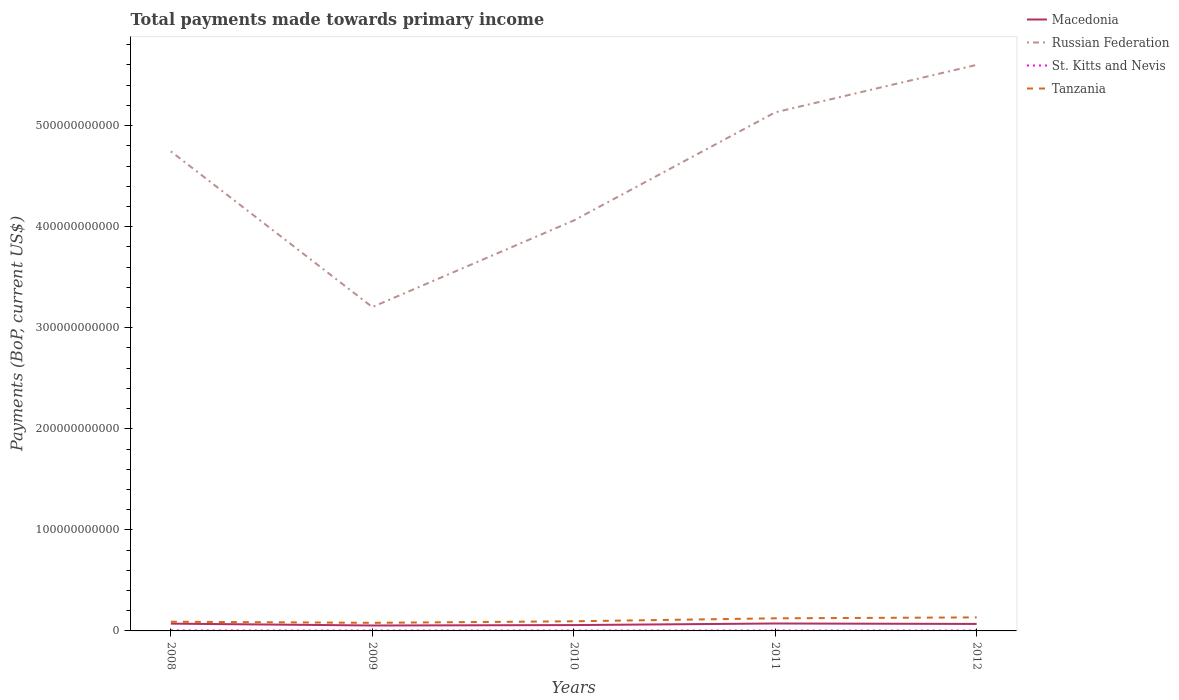How many different coloured lines are there?
Offer a very short reply. 4. Does the line corresponding to Macedonia intersect with the line corresponding to Tanzania?
Your answer should be very brief. No. Across all years, what is the maximum total payments made towards primary income in Macedonia?
Provide a succinct answer. 5.38e+09. In which year was the total payments made towards primary income in Tanzania maximum?
Give a very brief answer. 2009. What is the total total payments made towards primary income in Macedonia in the graph?
Ensure brevity in your answer.  -1.54e+09. What is the difference between the highest and the second highest total payments made towards primary income in Russian Federation?
Provide a short and direct response. 2.40e+11. What is the difference between the highest and the lowest total payments made towards primary income in Russian Federation?
Your response must be concise. 3. How many years are there in the graph?
Ensure brevity in your answer.  5. What is the difference between two consecutive major ticks on the Y-axis?
Offer a very short reply. 1.00e+11. Are the values on the major ticks of Y-axis written in scientific E-notation?
Ensure brevity in your answer.  No. Does the graph contain grids?
Ensure brevity in your answer.  No. Where does the legend appear in the graph?
Keep it short and to the point. Top right. How many legend labels are there?
Provide a succinct answer. 4. What is the title of the graph?
Your response must be concise. Total payments made towards primary income. What is the label or title of the X-axis?
Give a very brief answer. Years. What is the label or title of the Y-axis?
Provide a short and direct response. Payments (BoP, current US$). What is the Payments (BoP, current US$) of Macedonia in 2008?
Your answer should be compact. 7.21e+09. What is the Payments (BoP, current US$) in Russian Federation in 2008?
Offer a terse response. 4.75e+11. What is the Payments (BoP, current US$) of St. Kitts and Nevis in 2008?
Your answer should be compact. 4.81e+08. What is the Payments (BoP, current US$) in Tanzania in 2008?
Make the answer very short. 9.11e+09. What is the Payments (BoP, current US$) in Macedonia in 2009?
Make the answer very short. 5.38e+09. What is the Payments (BoP, current US$) of Russian Federation in 2009?
Ensure brevity in your answer.  3.20e+11. What is the Payments (BoP, current US$) in St. Kitts and Nevis in 2009?
Offer a very short reply. 4.11e+08. What is the Payments (BoP, current US$) in Tanzania in 2009?
Ensure brevity in your answer.  8.02e+09. What is the Payments (BoP, current US$) in Macedonia in 2010?
Offer a terse response. 5.79e+09. What is the Payments (BoP, current US$) in Russian Federation in 2010?
Keep it short and to the point. 4.06e+11. What is the Payments (BoP, current US$) of St. Kitts and Nevis in 2010?
Ensure brevity in your answer.  4.01e+08. What is the Payments (BoP, current US$) in Tanzania in 2010?
Give a very brief answer. 9.54e+09. What is the Payments (BoP, current US$) in Macedonia in 2011?
Provide a short and direct response. 7.35e+09. What is the Payments (BoP, current US$) in Russian Federation in 2011?
Provide a succinct answer. 5.13e+11. What is the Payments (BoP, current US$) in St. Kitts and Nevis in 2011?
Your answer should be very brief. 3.98e+08. What is the Payments (BoP, current US$) in Tanzania in 2011?
Your response must be concise. 1.25e+1. What is the Payments (BoP, current US$) of Macedonia in 2012?
Your answer should be compact. 6.92e+09. What is the Payments (BoP, current US$) of Russian Federation in 2012?
Provide a short and direct response. 5.60e+11. What is the Payments (BoP, current US$) of St. Kitts and Nevis in 2012?
Your answer should be compact. 3.76e+08. What is the Payments (BoP, current US$) in Tanzania in 2012?
Give a very brief answer. 1.34e+1. Across all years, what is the maximum Payments (BoP, current US$) of Macedonia?
Your answer should be very brief. 7.35e+09. Across all years, what is the maximum Payments (BoP, current US$) in Russian Federation?
Your answer should be very brief. 5.60e+11. Across all years, what is the maximum Payments (BoP, current US$) in St. Kitts and Nevis?
Give a very brief answer. 4.81e+08. Across all years, what is the maximum Payments (BoP, current US$) in Tanzania?
Provide a succinct answer. 1.34e+1. Across all years, what is the minimum Payments (BoP, current US$) in Macedonia?
Keep it short and to the point. 5.38e+09. Across all years, what is the minimum Payments (BoP, current US$) in Russian Federation?
Provide a short and direct response. 3.20e+11. Across all years, what is the minimum Payments (BoP, current US$) of St. Kitts and Nevis?
Keep it short and to the point. 3.76e+08. Across all years, what is the minimum Payments (BoP, current US$) of Tanzania?
Ensure brevity in your answer.  8.02e+09. What is the total Payments (BoP, current US$) in Macedonia in the graph?
Your answer should be very brief. 3.26e+1. What is the total Payments (BoP, current US$) in Russian Federation in the graph?
Your response must be concise. 2.27e+12. What is the total Payments (BoP, current US$) in St. Kitts and Nevis in the graph?
Make the answer very short. 2.07e+09. What is the total Payments (BoP, current US$) of Tanzania in the graph?
Give a very brief answer. 5.25e+1. What is the difference between the Payments (BoP, current US$) in Macedonia in 2008 and that in 2009?
Provide a short and direct response. 1.83e+09. What is the difference between the Payments (BoP, current US$) of Russian Federation in 2008 and that in 2009?
Keep it short and to the point. 1.54e+11. What is the difference between the Payments (BoP, current US$) in St. Kitts and Nevis in 2008 and that in 2009?
Keep it short and to the point. 7.06e+07. What is the difference between the Payments (BoP, current US$) in Tanzania in 2008 and that in 2009?
Give a very brief answer. 1.10e+09. What is the difference between the Payments (BoP, current US$) in Macedonia in 2008 and that in 2010?
Ensure brevity in your answer.  1.42e+09. What is the difference between the Payments (BoP, current US$) of Russian Federation in 2008 and that in 2010?
Your answer should be very brief. 6.84e+1. What is the difference between the Payments (BoP, current US$) in St. Kitts and Nevis in 2008 and that in 2010?
Provide a succinct answer. 8.02e+07. What is the difference between the Payments (BoP, current US$) in Tanzania in 2008 and that in 2010?
Keep it short and to the point. -4.30e+08. What is the difference between the Payments (BoP, current US$) of Macedonia in 2008 and that in 2011?
Keep it short and to the point. -1.41e+08. What is the difference between the Payments (BoP, current US$) of Russian Federation in 2008 and that in 2011?
Ensure brevity in your answer.  -3.86e+1. What is the difference between the Payments (BoP, current US$) of St. Kitts and Nevis in 2008 and that in 2011?
Ensure brevity in your answer.  8.34e+07. What is the difference between the Payments (BoP, current US$) in Tanzania in 2008 and that in 2011?
Keep it short and to the point. -3.37e+09. What is the difference between the Payments (BoP, current US$) of Macedonia in 2008 and that in 2012?
Make the answer very short. 2.89e+08. What is the difference between the Payments (BoP, current US$) in Russian Federation in 2008 and that in 2012?
Provide a short and direct response. -8.56e+1. What is the difference between the Payments (BoP, current US$) in St. Kitts and Nevis in 2008 and that in 2012?
Keep it short and to the point. 1.05e+08. What is the difference between the Payments (BoP, current US$) in Tanzania in 2008 and that in 2012?
Offer a very short reply. -4.27e+09. What is the difference between the Payments (BoP, current US$) of Macedonia in 2009 and that in 2010?
Provide a succinct answer. -4.10e+08. What is the difference between the Payments (BoP, current US$) of Russian Federation in 2009 and that in 2010?
Offer a terse response. -8.57e+1. What is the difference between the Payments (BoP, current US$) in St. Kitts and Nevis in 2009 and that in 2010?
Give a very brief answer. 9.59e+06. What is the difference between the Payments (BoP, current US$) in Tanzania in 2009 and that in 2010?
Make the answer very short. -1.53e+09. What is the difference between the Payments (BoP, current US$) of Macedonia in 2009 and that in 2011?
Ensure brevity in your answer.  -1.97e+09. What is the difference between the Payments (BoP, current US$) in Russian Federation in 2009 and that in 2011?
Make the answer very short. -1.93e+11. What is the difference between the Payments (BoP, current US$) of St. Kitts and Nevis in 2009 and that in 2011?
Offer a terse response. 1.28e+07. What is the difference between the Payments (BoP, current US$) of Tanzania in 2009 and that in 2011?
Keep it short and to the point. -4.46e+09. What is the difference between the Payments (BoP, current US$) of Macedonia in 2009 and that in 2012?
Offer a very short reply. -1.54e+09. What is the difference between the Payments (BoP, current US$) of Russian Federation in 2009 and that in 2012?
Provide a short and direct response. -2.40e+11. What is the difference between the Payments (BoP, current US$) in St. Kitts and Nevis in 2009 and that in 2012?
Your answer should be very brief. 3.41e+07. What is the difference between the Payments (BoP, current US$) in Tanzania in 2009 and that in 2012?
Your response must be concise. -5.37e+09. What is the difference between the Payments (BoP, current US$) in Macedonia in 2010 and that in 2011?
Offer a terse response. -1.56e+09. What is the difference between the Payments (BoP, current US$) of Russian Federation in 2010 and that in 2011?
Give a very brief answer. -1.07e+11. What is the difference between the Payments (BoP, current US$) in St. Kitts and Nevis in 2010 and that in 2011?
Offer a terse response. 3.21e+06. What is the difference between the Payments (BoP, current US$) in Tanzania in 2010 and that in 2011?
Make the answer very short. -2.94e+09. What is the difference between the Payments (BoP, current US$) in Macedonia in 2010 and that in 2012?
Your response must be concise. -1.13e+09. What is the difference between the Payments (BoP, current US$) in Russian Federation in 2010 and that in 2012?
Provide a short and direct response. -1.54e+11. What is the difference between the Payments (BoP, current US$) in St. Kitts and Nevis in 2010 and that in 2012?
Offer a very short reply. 2.45e+07. What is the difference between the Payments (BoP, current US$) of Tanzania in 2010 and that in 2012?
Provide a succinct answer. -3.84e+09. What is the difference between the Payments (BoP, current US$) of Macedonia in 2011 and that in 2012?
Offer a terse response. 4.29e+08. What is the difference between the Payments (BoP, current US$) of Russian Federation in 2011 and that in 2012?
Offer a terse response. -4.70e+1. What is the difference between the Payments (BoP, current US$) of St. Kitts and Nevis in 2011 and that in 2012?
Your answer should be very brief. 2.13e+07. What is the difference between the Payments (BoP, current US$) in Tanzania in 2011 and that in 2012?
Ensure brevity in your answer.  -9.06e+08. What is the difference between the Payments (BoP, current US$) in Macedonia in 2008 and the Payments (BoP, current US$) in Russian Federation in 2009?
Offer a very short reply. -3.13e+11. What is the difference between the Payments (BoP, current US$) of Macedonia in 2008 and the Payments (BoP, current US$) of St. Kitts and Nevis in 2009?
Provide a short and direct response. 6.80e+09. What is the difference between the Payments (BoP, current US$) of Macedonia in 2008 and the Payments (BoP, current US$) of Tanzania in 2009?
Offer a very short reply. -8.09e+08. What is the difference between the Payments (BoP, current US$) in Russian Federation in 2008 and the Payments (BoP, current US$) in St. Kitts and Nevis in 2009?
Ensure brevity in your answer.  4.74e+11. What is the difference between the Payments (BoP, current US$) in Russian Federation in 2008 and the Payments (BoP, current US$) in Tanzania in 2009?
Ensure brevity in your answer.  4.67e+11. What is the difference between the Payments (BoP, current US$) in St. Kitts and Nevis in 2008 and the Payments (BoP, current US$) in Tanzania in 2009?
Your answer should be compact. -7.53e+09. What is the difference between the Payments (BoP, current US$) of Macedonia in 2008 and the Payments (BoP, current US$) of Russian Federation in 2010?
Keep it short and to the point. -3.99e+11. What is the difference between the Payments (BoP, current US$) in Macedonia in 2008 and the Payments (BoP, current US$) in St. Kitts and Nevis in 2010?
Give a very brief answer. 6.81e+09. What is the difference between the Payments (BoP, current US$) of Macedonia in 2008 and the Payments (BoP, current US$) of Tanzania in 2010?
Your response must be concise. -2.34e+09. What is the difference between the Payments (BoP, current US$) in Russian Federation in 2008 and the Payments (BoP, current US$) in St. Kitts and Nevis in 2010?
Offer a very short reply. 4.74e+11. What is the difference between the Payments (BoP, current US$) of Russian Federation in 2008 and the Payments (BoP, current US$) of Tanzania in 2010?
Keep it short and to the point. 4.65e+11. What is the difference between the Payments (BoP, current US$) in St. Kitts and Nevis in 2008 and the Payments (BoP, current US$) in Tanzania in 2010?
Offer a very short reply. -9.06e+09. What is the difference between the Payments (BoP, current US$) of Macedonia in 2008 and the Payments (BoP, current US$) of Russian Federation in 2011?
Give a very brief answer. -5.06e+11. What is the difference between the Payments (BoP, current US$) in Macedonia in 2008 and the Payments (BoP, current US$) in St. Kitts and Nevis in 2011?
Provide a succinct answer. 6.81e+09. What is the difference between the Payments (BoP, current US$) of Macedonia in 2008 and the Payments (BoP, current US$) of Tanzania in 2011?
Give a very brief answer. -5.27e+09. What is the difference between the Payments (BoP, current US$) of Russian Federation in 2008 and the Payments (BoP, current US$) of St. Kitts and Nevis in 2011?
Your answer should be very brief. 4.74e+11. What is the difference between the Payments (BoP, current US$) of Russian Federation in 2008 and the Payments (BoP, current US$) of Tanzania in 2011?
Offer a terse response. 4.62e+11. What is the difference between the Payments (BoP, current US$) of St. Kitts and Nevis in 2008 and the Payments (BoP, current US$) of Tanzania in 2011?
Make the answer very short. -1.20e+1. What is the difference between the Payments (BoP, current US$) in Macedonia in 2008 and the Payments (BoP, current US$) in Russian Federation in 2012?
Your answer should be compact. -5.53e+11. What is the difference between the Payments (BoP, current US$) in Macedonia in 2008 and the Payments (BoP, current US$) in St. Kitts and Nevis in 2012?
Keep it short and to the point. 6.83e+09. What is the difference between the Payments (BoP, current US$) in Macedonia in 2008 and the Payments (BoP, current US$) in Tanzania in 2012?
Keep it short and to the point. -6.18e+09. What is the difference between the Payments (BoP, current US$) in Russian Federation in 2008 and the Payments (BoP, current US$) in St. Kitts and Nevis in 2012?
Give a very brief answer. 4.74e+11. What is the difference between the Payments (BoP, current US$) of Russian Federation in 2008 and the Payments (BoP, current US$) of Tanzania in 2012?
Your answer should be compact. 4.61e+11. What is the difference between the Payments (BoP, current US$) in St. Kitts and Nevis in 2008 and the Payments (BoP, current US$) in Tanzania in 2012?
Provide a short and direct response. -1.29e+1. What is the difference between the Payments (BoP, current US$) of Macedonia in 2009 and the Payments (BoP, current US$) of Russian Federation in 2010?
Provide a short and direct response. -4.01e+11. What is the difference between the Payments (BoP, current US$) of Macedonia in 2009 and the Payments (BoP, current US$) of St. Kitts and Nevis in 2010?
Keep it short and to the point. 4.98e+09. What is the difference between the Payments (BoP, current US$) of Macedonia in 2009 and the Payments (BoP, current US$) of Tanzania in 2010?
Ensure brevity in your answer.  -4.16e+09. What is the difference between the Payments (BoP, current US$) of Russian Federation in 2009 and the Payments (BoP, current US$) of St. Kitts and Nevis in 2010?
Your answer should be compact. 3.20e+11. What is the difference between the Payments (BoP, current US$) of Russian Federation in 2009 and the Payments (BoP, current US$) of Tanzania in 2010?
Your answer should be compact. 3.11e+11. What is the difference between the Payments (BoP, current US$) in St. Kitts and Nevis in 2009 and the Payments (BoP, current US$) in Tanzania in 2010?
Your answer should be very brief. -9.13e+09. What is the difference between the Payments (BoP, current US$) in Macedonia in 2009 and the Payments (BoP, current US$) in Russian Federation in 2011?
Make the answer very short. -5.08e+11. What is the difference between the Payments (BoP, current US$) of Macedonia in 2009 and the Payments (BoP, current US$) of St. Kitts and Nevis in 2011?
Provide a short and direct response. 4.98e+09. What is the difference between the Payments (BoP, current US$) of Macedonia in 2009 and the Payments (BoP, current US$) of Tanzania in 2011?
Provide a short and direct response. -7.10e+09. What is the difference between the Payments (BoP, current US$) of Russian Federation in 2009 and the Payments (BoP, current US$) of St. Kitts and Nevis in 2011?
Keep it short and to the point. 3.20e+11. What is the difference between the Payments (BoP, current US$) of Russian Federation in 2009 and the Payments (BoP, current US$) of Tanzania in 2011?
Provide a short and direct response. 3.08e+11. What is the difference between the Payments (BoP, current US$) of St. Kitts and Nevis in 2009 and the Payments (BoP, current US$) of Tanzania in 2011?
Keep it short and to the point. -1.21e+1. What is the difference between the Payments (BoP, current US$) of Macedonia in 2009 and the Payments (BoP, current US$) of Russian Federation in 2012?
Ensure brevity in your answer.  -5.55e+11. What is the difference between the Payments (BoP, current US$) of Macedonia in 2009 and the Payments (BoP, current US$) of St. Kitts and Nevis in 2012?
Provide a short and direct response. 5.00e+09. What is the difference between the Payments (BoP, current US$) in Macedonia in 2009 and the Payments (BoP, current US$) in Tanzania in 2012?
Keep it short and to the point. -8.00e+09. What is the difference between the Payments (BoP, current US$) of Russian Federation in 2009 and the Payments (BoP, current US$) of St. Kitts and Nevis in 2012?
Give a very brief answer. 3.20e+11. What is the difference between the Payments (BoP, current US$) of Russian Federation in 2009 and the Payments (BoP, current US$) of Tanzania in 2012?
Offer a terse response. 3.07e+11. What is the difference between the Payments (BoP, current US$) in St. Kitts and Nevis in 2009 and the Payments (BoP, current US$) in Tanzania in 2012?
Offer a very short reply. -1.30e+1. What is the difference between the Payments (BoP, current US$) of Macedonia in 2010 and the Payments (BoP, current US$) of Russian Federation in 2011?
Make the answer very short. -5.07e+11. What is the difference between the Payments (BoP, current US$) of Macedonia in 2010 and the Payments (BoP, current US$) of St. Kitts and Nevis in 2011?
Provide a short and direct response. 5.39e+09. What is the difference between the Payments (BoP, current US$) in Macedonia in 2010 and the Payments (BoP, current US$) in Tanzania in 2011?
Ensure brevity in your answer.  -6.69e+09. What is the difference between the Payments (BoP, current US$) of Russian Federation in 2010 and the Payments (BoP, current US$) of St. Kitts and Nevis in 2011?
Ensure brevity in your answer.  4.06e+11. What is the difference between the Payments (BoP, current US$) of Russian Federation in 2010 and the Payments (BoP, current US$) of Tanzania in 2011?
Make the answer very short. 3.94e+11. What is the difference between the Payments (BoP, current US$) of St. Kitts and Nevis in 2010 and the Payments (BoP, current US$) of Tanzania in 2011?
Offer a terse response. -1.21e+1. What is the difference between the Payments (BoP, current US$) of Macedonia in 2010 and the Payments (BoP, current US$) of Russian Federation in 2012?
Ensure brevity in your answer.  -5.54e+11. What is the difference between the Payments (BoP, current US$) of Macedonia in 2010 and the Payments (BoP, current US$) of St. Kitts and Nevis in 2012?
Give a very brief answer. 5.41e+09. What is the difference between the Payments (BoP, current US$) of Macedonia in 2010 and the Payments (BoP, current US$) of Tanzania in 2012?
Your answer should be very brief. -7.59e+09. What is the difference between the Payments (BoP, current US$) in Russian Federation in 2010 and the Payments (BoP, current US$) in St. Kitts and Nevis in 2012?
Provide a short and direct response. 4.06e+11. What is the difference between the Payments (BoP, current US$) of Russian Federation in 2010 and the Payments (BoP, current US$) of Tanzania in 2012?
Offer a terse response. 3.93e+11. What is the difference between the Payments (BoP, current US$) of St. Kitts and Nevis in 2010 and the Payments (BoP, current US$) of Tanzania in 2012?
Your answer should be compact. -1.30e+1. What is the difference between the Payments (BoP, current US$) in Macedonia in 2011 and the Payments (BoP, current US$) in Russian Federation in 2012?
Make the answer very short. -5.53e+11. What is the difference between the Payments (BoP, current US$) in Macedonia in 2011 and the Payments (BoP, current US$) in St. Kitts and Nevis in 2012?
Your answer should be compact. 6.97e+09. What is the difference between the Payments (BoP, current US$) in Macedonia in 2011 and the Payments (BoP, current US$) in Tanzania in 2012?
Your response must be concise. -6.04e+09. What is the difference between the Payments (BoP, current US$) in Russian Federation in 2011 and the Payments (BoP, current US$) in St. Kitts and Nevis in 2012?
Provide a succinct answer. 5.13e+11. What is the difference between the Payments (BoP, current US$) of Russian Federation in 2011 and the Payments (BoP, current US$) of Tanzania in 2012?
Ensure brevity in your answer.  5.00e+11. What is the difference between the Payments (BoP, current US$) in St. Kitts and Nevis in 2011 and the Payments (BoP, current US$) in Tanzania in 2012?
Give a very brief answer. -1.30e+1. What is the average Payments (BoP, current US$) in Macedonia per year?
Keep it short and to the point. 6.53e+09. What is the average Payments (BoP, current US$) in Russian Federation per year?
Ensure brevity in your answer.  4.55e+11. What is the average Payments (BoP, current US$) in St. Kitts and Nevis per year?
Offer a terse response. 4.13e+08. What is the average Payments (BoP, current US$) of Tanzania per year?
Your answer should be compact. 1.05e+1. In the year 2008, what is the difference between the Payments (BoP, current US$) of Macedonia and Payments (BoP, current US$) of Russian Federation?
Provide a short and direct response. -4.67e+11. In the year 2008, what is the difference between the Payments (BoP, current US$) of Macedonia and Payments (BoP, current US$) of St. Kitts and Nevis?
Ensure brevity in your answer.  6.73e+09. In the year 2008, what is the difference between the Payments (BoP, current US$) of Macedonia and Payments (BoP, current US$) of Tanzania?
Offer a terse response. -1.90e+09. In the year 2008, what is the difference between the Payments (BoP, current US$) in Russian Federation and Payments (BoP, current US$) in St. Kitts and Nevis?
Offer a terse response. 4.74e+11. In the year 2008, what is the difference between the Payments (BoP, current US$) in Russian Federation and Payments (BoP, current US$) in Tanzania?
Offer a very short reply. 4.65e+11. In the year 2008, what is the difference between the Payments (BoP, current US$) of St. Kitts and Nevis and Payments (BoP, current US$) of Tanzania?
Make the answer very short. -8.63e+09. In the year 2009, what is the difference between the Payments (BoP, current US$) of Macedonia and Payments (BoP, current US$) of Russian Federation?
Provide a short and direct response. -3.15e+11. In the year 2009, what is the difference between the Payments (BoP, current US$) in Macedonia and Payments (BoP, current US$) in St. Kitts and Nevis?
Offer a very short reply. 4.97e+09. In the year 2009, what is the difference between the Payments (BoP, current US$) in Macedonia and Payments (BoP, current US$) in Tanzania?
Give a very brief answer. -2.64e+09. In the year 2009, what is the difference between the Payments (BoP, current US$) in Russian Federation and Payments (BoP, current US$) in St. Kitts and Nevis?
Offer a terse response. 3.20e+11. In the year 2009, what is the difference between the Payments (BoP, current US$) of Russian Federation and Payments (BoP, current US$) of Tanzania?
Ensure brevity in your answer.  3.12e+11. In the year 2009, what is the difference between the Payments (BoP, current US$) in St. Kitts and Nevis and Payments (BoP, current US$) in Tanzania?
Your answer should be compact. -7.60e+09. In the year 2010, what is the difference between the Payments (BoP, current US$) in Macedonia and Payments (BoP, current US$) in Russian Federation?
Provide a succinct answer. -4.00e+11. In the year 2010, what is the difference between the Payments (BoP, current US$) of Macedonia and Payments (BoP, current US$) of St. Kitts and Nevis?
Your response must be concise. 5.39e+09. In the year 2010, what is the difference between the Payments (BoP, current US$) of Macedonia and Payments (BoP, current US$) of Tanzania?
Keep it short and to the point. -3.75e+09. In the year 2010, what is the difference between the Payments (BoP, current US$) of Russian Federation and Payments (BoP, current US$) of St. Kitts and Nevis?
Ensure brevity in your answer.  4.06e+11. In the year 2010, what is the difference between the Payments (BoP, current US$) of Russian Federation and Payments (BoP, current US$) of Tanzania?
Keep it short and to the point. 3.97e+11. In the year 2010, what is the difference between the Payments (BoP, current US$) in St. Kitts and Nevis and Payments (BoP, current US$) in Tanzania?
Your response must be concise. -9.14e+09. In the year 2011, what is the difference between the Payments (BoP, current US$) in Macedonia and Payments (BoP, current US$) in Russian Federation?
Keep it short and to the point. -5.06e+11. In the year 2011, what is the difference between the Payments (BoP, current US$) in Macedonia and Payments (BoP, current US$) in St. Kitts and Nevis?
Give a very brief answer. 6.95e+09. In the year 2011, what is the difference between the Payments (BoP, current US$) of Macedonia and Payments (BoP, current US$) of Tanzania?
Offer a terse response. -5.13e+09. In the year 2011, what is the difference between the Payments (BoP, current US$) in Russian Federation and Payments (BoP, current US$) in St. Kitts and Nevis?
Offer a terse response. 5.13e+11. In the year 2011, what is the difference between the Payments (BoP, current US$) of Russian Federation and Payments (BoP, current US$) of Tanzania?
Keep it short and to the point. 5.01e+11. In the year 2011, what is the difference between the Payments (BoP, current US$) in St. Kitts and Nevis and Payments (BoP, current US$) in Tanzania?
Provide a short and direct response. -1.21e+1. In the year 2012, what is the difference between the Payments (BoP, current US$) of Macedonia and Payments (BoP, current US$) of Russian Federation?
Offer a very short reply. -5.53e+11. In the year 2012, what is the difference between the Payments (BoP, current US$) in Macedonia and Payments (BoP, current US$) in St. Kitts and Nevis?
Your answer should be compact. 6.54e+09. In the year 2012, what is the difference between the Payments (BoP, current US$) of Macedonia and Payments (BoP, current US$) of Tanzania?
Ensure brevity in your answer.  -6.47e+09. In the year 2012, what is the difference between the Payments (BoP, current US$) in Russian Federation and Payments (BoP, current US$) in St. Kitts and Nevis?
Give a very brief answer. 5.60e+11. In the year 2012, what is the difference between the Payments (BoP, current US$) in Russian Federation and Payments (BoP, current US$) in Tanzania?
Your response must be concise. 5.47e+11. In the year 2012, what is the difference between the Payments (BoP, current US$) of St. Kitts and Nevis and Payments (BoP, current US$) of Tanzania?
Your response must be concise. -1.30e+1. What is the ratio of the Payments (BoP, current US$) of Macedonia in 2008 to that in 2009?
Ensure brevity in your answer.  1.34. What is the ratio of the Payments (BoP, current US$) in Russian Federation in 2008 to that in 2009?
Give a very brief answer. 1.48. What is the ratio of the Payments (BoP, current US$) in St. Kitts and Nevis in 2008 to that in 2009?
Provide a short and direct response. 1.17. What is the ratio of the Payments (BoP, current US$) of Tanzania in 2008 to that in 2009?
Your response must be concise. 1.14. What is the ratio of the Payments (BoP, current US$) of Macedonia in 2008 to that in 2010?
Provide a succinct answer. 1.24. What is the ratio of the Payments (BoP, current US$) in Russian Federation in 2008 to that in 2010?
Your answer should be very brief. 1.17. What is the ratio of the Payments (BoP, current US$) of St. Kitts and Nevis in 2008 to that in 2010?
Give a very brief answer. 1.2. What is the ratio of the Payments (BoP, current US$) of Tanzania in 2008 to that in 2010?
Your response must be concise. 0.95. What is the ratio of the Payments (BoP, current US$) in Macedonia in 2008 to that in 2011?
Offer a terse response. 0.98. What is the ratio of the Payments (BoP, current US$) of Russian Federation in 2008 to that in 2011?
Ensure brevity in your answer.  0.92. What is the ratio of the Payments (BoP, current US$) of St. Kitts and Nevis in 2008 to that in 2011?
Provide a succinct answer. 1.21. What is the ratio of the Payments (BoP, current US$) of Tanzania in 2008 to that in 2011?
Provide a succinct answer. 0.73. What is the ratio of the Payments (BoP, current US$) in Macedonia in 2008 to that in 2012?
Your answer should be very brief. 1.04. What is the ratio of the Payments (BoP, current US$) in Russian Federation in 2008 to that in 2012?
Your answer should be compact. 0.85. What is the ratio of the Payments (BoP, current US$) in St. Kitts and Nevis in 2008 to that in 2012?
Keep it short and to the point. 1.28. What is the ratio of the Payments (BoP, current US$) of Tanzania in 2008 to that in 2012?
Offer a very short reply. 0.68. What is the ratio of the Payments (BoP, current US$) of Macedonia in 2009 to that in 2010?
Offer a terse response. 0.93. What is the ratio of the Payments (BoP, current US$) of Russian Federation in 2009 to that in 2010?
Provide a succinct answer. 0.79. What is the ratio of the Payments (BoP, current US$) in St. Kitts and Nevis in 2009 to that in 2010?
Your answer should be very brief. 1.02. What is the ratio of the Payments (BoP, current US$) in Tanzania in 2009 to that in 2010?
Your answer should be very brief. 0.84. What is the ratio of the Payments (BoP, current US$) in Macedonia in 2009 to that in 2011?
Your answer should be compact. 0.73. What is the ratio of the Payments (BoP, current US$) of Russian Federation in 2009 to that in 2011?
Your answer should be very brief. 0.62. What is the ratio of the Payments (BoP, current US$) in St. Kitts and Nevis in 2009 to that in 2011?
Give a very brief answer. 1.03. What is the ratio of the Payments (BoP, current US$) in Tanzania in 2009 to that in 2011?
Keep it short and to the point. 0.64. What is the ratio of the Payments (BoP, current US$) in Macedonia in 2009 to that in 2012?
Make the answer very short. 0.78. What is the ratio of the Payments (BoP, current US$) of Russian Federation in 2009 to that in 2012?
Give a very brief answer. 0.57. What is the ratio of the Payments (BoP, current US$) in St. Kitts and Nevis in 2009 to that in 2012?
Provide a succinct answer. 1.09. What is the ratio of the Payments (BoP, current US$) in Tanzania in 2009 to that in 2012?
Your answer should be compact. 0.6. What is the ratio of the Payments (BoP, current US$) of Macedonia in 2010 to that in 2011?
Provide a short and direct response. 0.79. What is the ratio of the Payments (BoP, current US$) in Russian Federation in 2010 to that in 2011?
Your answer should be compact. 0.79. What is the ratio of the Payments (BoP, current US$) of St. Kitts and Nevis in 2010 to that in 2011?
Keep it short and to the point. 1.01. What is the ratio of the Payments (BoP, current US$) of Tanzania in 2010 to that in 2011?
Your answer should be compact. 0.76. What is the ratio of the Payments (BoP, current US$) in Macedonia in 2010 to that in 2012?
Provide a succinct answer. 0.84. What is the ratio of the Payments (BoP, current US$) of Russian Federation in 2010 to that in 2012?
Your answer should be very brief. 0.73. What is the ratio of the Payments (BoP, current US$) of St. Kitts and Nevis in 2010 to that in 2012?
Keep it short and to the point. 1.07. What is the ratio of the Payments (BoP, current US$) in Tanzania in 2010 to that in 2012?
Your answer should be very brief. 0.71. What is the ratio of the Payments (BoP, current US$) of Macedonia in 2011 to that in 2012?
Keep it short and to the point. 1.06. What is the ratio of the Payments (BoP, current US$) in Russian Federation in 2011 to that in 2012?
Your answer should be compact. 0.92. What is the ratio of the Payments (BoP, current US$) in St. Kitts and Nevis in 2011 to that in 2012?
Provide a succinct answer. 1.06. What is the ratio of the Payments (BoP, current US$) in Tanzania in 2011 to that in 2012?
Give a very brief answer. 0.93. What is the difference between the highest and the second highest Payments (BoP, current US$) of Macedonia?
Give a very brief answer. 1.41e+08. What is the difference between the highest and the second highest Payments (BoP, current US$) of Russian Federation?
Your answer should be compact. 4.70e+1. What is the difference between the highest and the second highest Payments (BoP, current US$) of St. Kitts and Nevis?
Make the answer very short. 7.06e+07. What is the difference between the highest and the second highest Payments (BoP, current US$) of Tanzania?
Give a very brief answer. 9.06e+08. What is the difference between the highest and the lowest Payments (BoP, current US$) of Macedonia?
Offer a very short reply. 1.97e+09. What is the difference between the highest and the lowest Payments (BoP, current US$) in Russian Federation?
Your response must be concise. 2.40e+11. What is the difference between the highest and the lowest Payments (BoP, current US$) in St. Kitts and Nevis?
Your answer should be very brief. 1.05e+08. What is the difference between the highest and the lowest Payments (BoP, current US$) in Tanzania?
Provide a short and direct response. 5.37e+09. 